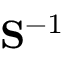<formula> <loc_0><loc_0><loc_500><loc_500>{ S } ^ { - 1 }</formula> 